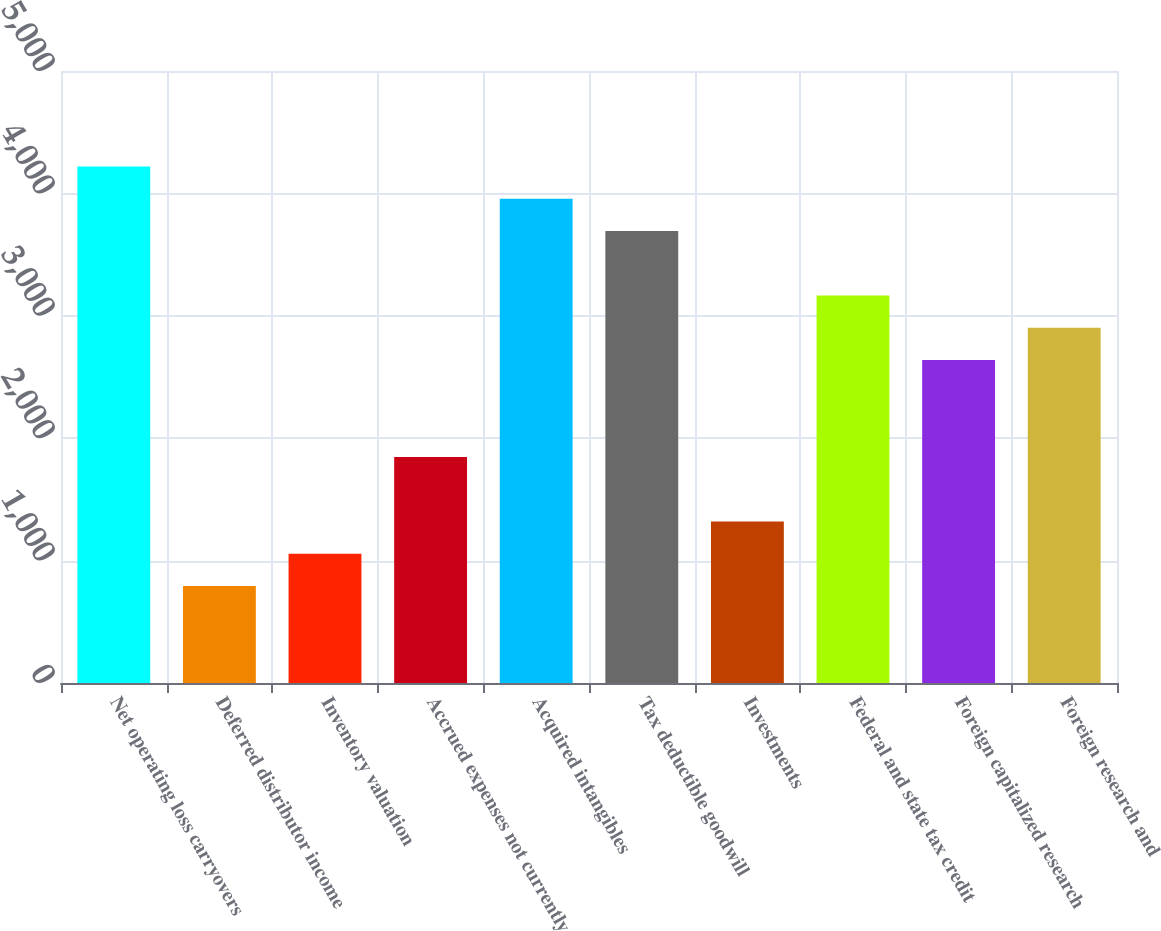Convert chart. <chart><loc_0><loc_0><loc_500><loc_500><bar_chart><fcel>Net operating loss carryovers<fcel>Deferred distributor income<fcel>Inventory valuation<fcel>Accrued expenses not currently<fcel>Acquired intangibles<fcel>Tax deductible goodwill<fcel>Investments<fcel>Federal and state tax credit<fcel>Foreign capitalized research<fcel>Foreign research and<nl><fcel>4220.01<fcel>792.3<fcel>1055.97<fcel>1846.98<fcel>3956.34<fcel>3692.67<fcel>1319.64<fcel>3165.33<fcel>2637.99<fcel>2901.66<nl></chart> 